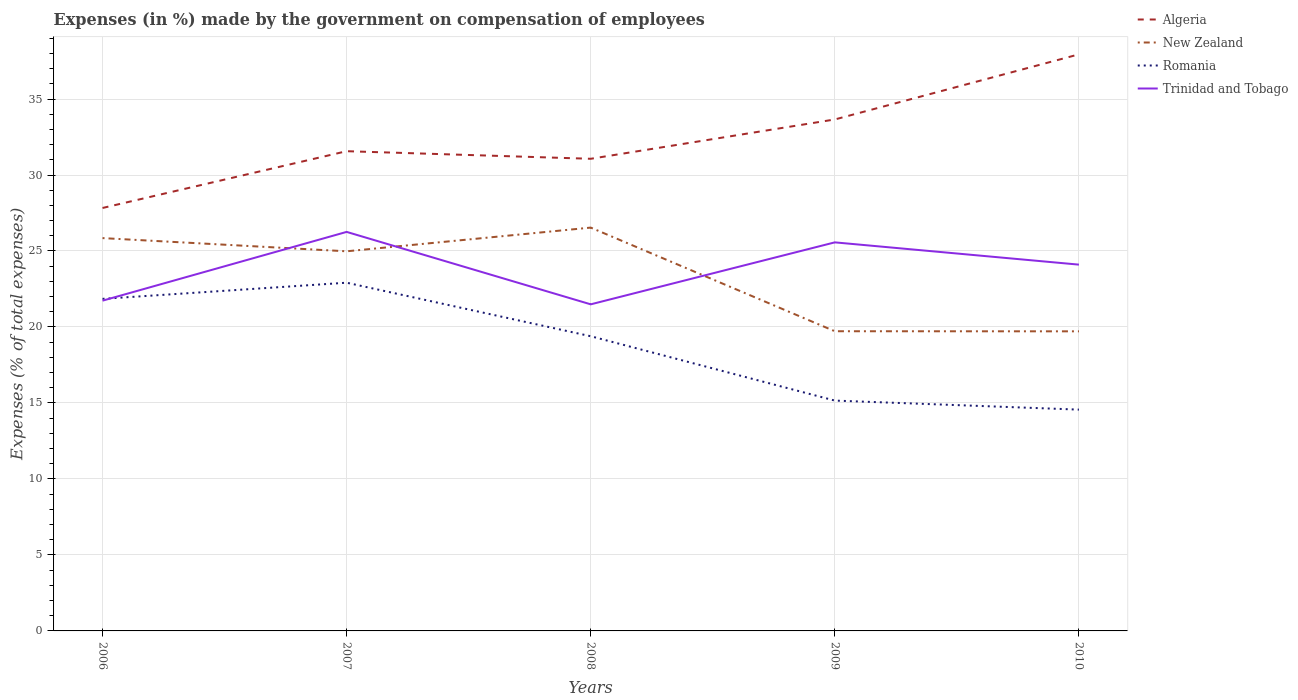Does the line corresponding to New Zealand intersect with the line corresponding to Trinidad and Tobago?
Provide a short and direct response. Yes. Across all years, what is the maximum percentage of expenses made by the government on compensation of employees in Trinidad and Tobago?
Offer a very short reply. 21.49. What is the total percentage of expenses made by the government on compensation of employees in New Zealand in the graph?
Your answer should be compact. 6.14. What is the difference between the highest and the second highest percentage of expenses made by the government on compensation of employees in Romania?
Provide a short and direct response. 8.35. How many lines are there?
Offer a very short reply. 4. How many years are there in the graph?
Provide a short and direct response. 5. What is the difference between two consecutive major ticks on the Y-axis?
Your answer should be compact. 5. Where does the legend appear in the graph?
Provide a short and direct response. Top right. How are the legend labels stacked?
Your response must be concise. Vertical. What is the title of the graph?
Your response must be concise. Expenses (in %) made by the government on compensation of employees. Does "Greece" appear as one of the legend labels in the graph?
Provide a succinct answer. No. What is the label or title of the Y-axis?
Your answer should be very brief. Expenses (% of total expenses). What is the Expenses (% of total expenses) in Algeria in 2006?
Your response must be concise. 27.83. What is the Expenses (% of total expenses) in New Zealand in 2006?
Ensure brevity in your answer.  25.85. What is the Expenses (% of total expenses) of Romania in 2006?
Your answer should be compact. 21.85. What is the Expenses (% of total expenses) in Trinidad and Tobago in 2006?
Ensure brevity in your answer.  21.73. What is the Expenses (% of total expenses) of Algeria in 2007?
Offer a terse response. 31.57. What is the Expenses (% of total expenses) in New Zealand in 2007?
Make the answer very short. 24.98. What is the Expenses (% of total expenses) in Romania in 2007?
Give a very brief answer. 22.91. What is the Expenses (% of total expenses) of Trinidad and Tobago in 2007?
Your answer should be compact. 26.26. What is the Expenses (% of total expenses) of Algeria in 2008?
Your response must be concise. 31.07. What is the Expenses (% of total expenses) in New Zealand in 2008?
Your answer should be very brief. 26.54. What is the Expenses (% of total expenses) of Romania in 2008?
Give a very brief answer. 19.39. What is the Expenses (% of total expenses) of Trinidad and Tobago in 2008?
Your answer should be very brief. 21.49. What is the Expenses (% of total expenses) of Algeria in 2009?
Offer a terse response. 33.66. What is the Expenses (% of total expenses) in New Zealand in 2009?
Your answer should be very brief. 19.72. What is the Expenses (% of total expenses) in Romania in 2009?
Make the answer very short. 15.16. What is the Expenses (% of total expenses) of Trinidad and Tobago in 2009?
Keep it short and to the point. 25.57. What is the Expenses (% of total expenses) in Algeria in 2010?
Your response must be concise. 37.94. What is the Expenses (% of total expenses) in New Zealand in 2010?
Make the answer very short. 19.71. What is the Expenses (% of total expenses) of Romania in 2010?
Provide a short and direct response. 14.56. What is the Expenses (% of total expenses) in Trinidad and Tobago in 2010?
Offer a very short reply. 24.1. Across all years, what is the maximum Expenses (% of total expenses) in Algeria?
Provide a succinct answer. 37.94. Across all years, what is the maximum Expenses (% of total expenses) of New Zealand?
Offer a terse response. 26.54. Across all years, what is the maximum Expenses (% of total expenses) in Romania?
Your answer should be very brief. 22.91. Across all years, what is the maximum Expenses (% of total expenses) in Trinidad and Tobago?
Offer a very short reply. 26.26. Across all years, what is the minimum Expenses (% of total expenses) of Algeria?
Your answer should be compact. 27.83. Across all years, what is the minimum Expenses (% of total expenses) in New Zealand?
Provide a succinct answer. 19.71. Across all years, what is the minimum Expenses (% of total expenses) in Romania?
Provide a succinct answer. 14.56. Across all years, what is the minimum Expenses (% of total expenses) of Trinidad and Tobago?
Keep it short and to the point. 21.49. What is the total Expenses (% of total expenses) in Algeria in the graph?
Keep it short and to the point. 162.06. What is the total Expenses (% of total expenses) of New Zealand in the graph?
Give a very brief answer. 116.8. What is the total Expenses (% of total expenses) of Romania in the graph?
Offer a very short reply. 93.87. What is the total Expenses (% of total expenses) of Trinidad and Tobago in the graph?
Give a very brief answer. 119.15. What is the difference between the Expenses (% of total expenses) in Algeria in 2006 and that in 2007?
Ensure brevity in your answer.  -3.74. What is the difference between the Expenses (% of total expenses) in New Zealand in 2006 and that in 2007?
Offer a terse response. 0.87. What is the difference between the Expenses (% of total expenses) in Romania in 2006 and that in 2007?
Keep it short and to the point. -1.06. What is the difference between the Expenses (% of total expenses) in Trinidad and Tobago in 2006 and that in 2007?
Offer a terse response. -4.53. What is the difference between the Expenses (% of total expenses) in Algeria in 2006 and that in 2008?
Your answer should be compact. -3.24. What is the difference between the Expenses (% of total expenses) of New Zealand in 2006 and that in 2008?
Offer a very short reply. -0.69. What is the difference between the Expenses (% of total expenses) in Romania in 2006 and that in 2008?
Give a very brief answer. 2.46. What is the difference between the Expenses (% of total expenses) in Trinidad and Tobago in 2006 and that in 2008?
Your answer should be compact. 0.24. What is the difference between the Expenses (% of total expenses) of Algeria in 2006 and that in 2009?
Provide a short and direct response. -5.83. What is the difference between the Expenses (% of total expenses) of New Zealand in 2006 and that in 2009?
Provide a succinct answer. 6.13. What is the difference between the Expenses (% of total expenses) in Romania in 2006 and that in 2009?
Offer a terse response. 6.69. What is the difference between the Expenses (% of total expenses) in Trinidad and Tobago in 2006 and that in 2009?
Give a very brief answer. -3.84. What is the difference between the Expenses (% of total expenses) of Algeria in 2006 and that in 2010?
Give a very brief answer. -10.11. What is the difference between the Expenses (% of total expenses) in New Zealand in 2006 and that in 2010?
Offer a very short reply. 6.14. What is the difference between the Expenses (% of total expenses) of Romania in 2006 and that in 2010?
Ensure brevity in your answer.  7.29. What is the difference between the Expenses (% of total expenses) in Trinidad and Tobago in 2006 and that in 2010?
Your answer should be compact. -2.37. What is the difference between the Expenses (% of total expenses) of Algeria in 2007 and that in 2008?
Your answer should be compact. 0.5. What is the difference between the Expenses (% of total expenses) in New Zealand in 2007 and that in 2008?
Make the answer very short. -1.56. What is the difference between the Expenses (% of total expenses) in Romania in 2007 and that in 2008?
Ensure brevity in your answer.  3.52. What is the difference between the Expenses (% of total expenses) in Trinidad and Tobago in 2007 and that in 2008?
Make the answer very short. 4.77. What is the difference between the Expenses (% of total expenses) in Algeria in 2007 and that in 2009?
Make the answer very short. -2.09. What is the difference between the Expenses (% of total expenses) in New Zealand in 2007 and that in 2009?
Make the answer very short. 5.26. What is the difference between the Expenses (% of total expenses) of Romania in 2007 and that in 2009?
Ensure brevity in your answer.  7.76. What is the difference between the Expenses (% of total expenses) of Trinidad and Tobago in 2007 and that in 2009?
Offer a terse response. 0.69. What is the difference between the Expenses (% of total expenses) of Algeria in 2007 and that in 2010?
Give a very brief answer. -6.37. What is the difference between the Expenses (% of total expenses) of New Zealand in 2007 and that in 2010?
Make the answer very short. 5.27. What is the difference between the Expenses (% of total expenses) in Romania in 2007 and that in 2010?
Offer a very short reply. 8.35. What is the difference between the Expenses (% of total expenses) in Trinidad and Tobago in 2007 and that in 2010?
Ensure brevity in your answer.  2.15. What is the difference between the Expenses (% of total expenses) of Algeria in 2008 and that in 2009?
Your answer should be compact. -2.59. What is the difference between the Expenses (% of total expenses) of New Zealand in 2008 and that in 2009?
Your answer should be very brief. 6.82. What is the difference between the Expenses (% of total expenses) in Romania in 2008 and that in 2009?
Make the answer very short. 4.23. What is the difference between the Expenses (% of total expenses) of Trinidad and Tobago in 2008 and that in 2009?
Provide a short and direct response. -4.08. What is the difference between the Expenses (% of total expenses) in Algeria in 2008 and that in 2010?
Offer a very short reply. -6.87. What is the difference between the Expenses (% of total expenses) in New Zealand in 2008 and that in 2010?
Your answer should be compact. 6.83. What is the difference between the Expenses (% of total expenses) in Romania in 2008 and that in 2010?
Keep it short and to the point. 4.83. What is the difference between the Expenses (% of total expenses) of Trinidad and Tobago in 2008 and that in 2010?
Your answer should be compact. -2.61. What is the difference between the Expenses (% of total expenses) in Algeria in 2009 and that in 2010?
Keep it short and to the point. -4.28. What is the difference between the Expenses (% of total expenses) of New Zealand in 2009 and that in 2010?
Ensure brevity in your answer.  0.01. What is the difference between the Expenses (% of total expenses) of Romania in 2009 and that in 2010?
Your answer should be very brief. 0.59. What is the difference between the Expenses (% of total expenses) of Trinidad and Tobago in 2009 and that in 2010?
Give a very brief answer. 1.47. What is the difference between the Expenses (% of total expenses) of Algeria in 2006 and the Expenses (% of total expenses) of New Zealand in 2007?
Your answer should be very brief. 2.85. What is the difference between the Expenses (% of total expenses) of Algeria in 2006 and the Expenses (% of total expenses) of Romania in 2007?
Your response must be concise. 4.92. What is the difference between the Expenses (% of total expenses) of Algeria in 2006 and the Expenses (% of total expenses) of Trinidad and Tobago in 2007?
Make the answer very short. 1.57. What is the difference between the Expenses (% of total expenses) of New Zealand in 2006 and the Expenses (% of total expenses) of Romania in 2007?
Your answer should be compact. 2.94. What is the difference between the Expenses (% of total expenses) in New Zealand in 2006 and the Expenses (% of total expenses) in Trinidad and Tobago in 2007?
Your response must be concise. -0.41. What is the difference between the Expenses (% of total expenses) of Romania in 2006 and the Expenses (% of total expenses) of Trinidad and Tobago in 2007?
Your answer should be very brief. -4.41. What is the difference between the Expenses (% of total expenses) in Algeria in 2006 and the Expenses (% of total expenses) in New Zealand in 2008?
Provide a short and direct response. 1.29. What is the difference between the Expenses (% of total expenses) of Algeria in 2006 and the Expenses (% of total expenses) of Romania in 2008?
Your answer should be very brief. 8.44. What is the difference between the Expenses (% of total expenses) of Algeria in 2006 and the Expenses (% of total expenses) of Trinidad and Tobago in 2008?
Provide a short and direct response. 6.34. What is the difference between the Expenses (% of total expenses) in New Zealand in 2006 and the Expenses (% of total expenses) in Romania in 2008?
Offer a terse response. 6.46. What is the difference between the Expenses (% of total expenses) of New Zealand in 2006 and the Expenses (% of total expenses) of Trinidad and Tobago in 2008?
Keep it short and to the point. 4.36. What is the difference between the Expenses (% of total expenses) in Romania in 2006 and the Expenses (% of total expenses) in Trinidad and Tobago in 2008?
Your answer should be compact. 0.36. What is the difference between the Expenses (% of total expenses) in Algeria in 2006 and the Expenses (% of total expenses) in New Zealand in 2009?
Provide a short and direct response. 8.11. What is the difference between the Expenses (% of total expenses) of Algeria in 2006 and the Expenses (% of total expenses) of Romania in 2009?
Give a very brief answer. 12.67. What is the difference between the Expenses (% of total expenses) in Algeria in 2006 and the Expenses (% of total expenses) in Trinidad and Tobago in 2009?
Keep it short and to the point. 2.26. What is the difference between the Expenses (% of total expenses) in New Zealand in 2006 and the Expenses (% of total expenses) in Romania in 2009?
Make the answer very short. 10.69. What is the difference between the Expenses (% of total expenses) of New Zealand in 2006 and the Expenses (% of total expenses) of Trinidad and Tobago in 2009?
Keep it short and to the point. 0.28. What is the difference between the Expenses (% of total expenses) of Romania in 2006 and the Expenses (% of total expenses) of Trinidad and Tobago in 2009?
Your answer should be compact. -3.72. What is the difference between the Expenses (% of total expenses) of Algeria in 2006 and the Expenses (% of total expenses) of New Zealand in 2010?
Your response must be concise. 8.12. What is the difference between the Expenses (% of total expenses) of Algeria in 2006 and the Expenses (% of total expenses) of Romania in 2010?
Your response must be concise. 13.27. What is the difference between the Expenses (% of total expenses) of Algeria in 2006 and the Expenses (% of total expenses) of Trinidad and Tobago in 2010?
Ensure brevity in your answer.  3.73. What is the difference between the Expenses (% of total expenses) in New Zealand in 2006 and the Expenses (% of total expenses) in Romania in 2010?
Provide a short and direct response. 11.29. What is the difference between the Expenses (% of total expenses) in New Zealand in 2006 and the Expenses (% of total expenses) in Trinidad and Tobago in 2010?
Provide a short and direct response. 1.75. What is the difference between the Expenses (% of total expenses) of Romania in 2006 and the Expenses (% of total expenses) of Trinidad and Tobago in 2010?
Give a very brief answer. -2.25. What is the difference between the Expenses (% of total expenses) of Algeria in 2007 and the Expenses (% of total expenses) of New Zealand in 2008?
Your response must be concise. 5.03. What is the difference between the Expenses (% of total expenses) of Algeria in 2007 and the Expenses (% of total expenses) of Romania in 2008?
Ensure brevity in your answer.  12.18. What is the difference between the Expenses (% of total expenses) of Algeria in 2007 and the Expenses (% of total expenses) of Trinidad and Tobago in 2008?
Offer a very short reply. 10.08. What is the difference between the Expenses (% of total expenses) in New Zealand in 2007 and the Expenses (% of total expenses) in Romania in 2008?
Offer a very short reply. 5.59. What is the difference between the Expenses (% of total expenses) in New Zealand in 2007 and the Expenses (% of total expenses) in Trinidad and Tobago in 2008?
Keep it short and to the point. 3.49. What is the difference between the Expenses (% of total expenses) in Romania in 2007 and the Expenses (% of total expenses) in Trinidad and Tobago in 2008?
Provide a short and direct response. 1.42. What is the difference between the Expenses (% of total expenses) in Algeria in 2007 and the Expenses (% of total expenses) in New Zealand in 2009?
Offer a very short reply. 11.85. What is the difference between the Expenses (% of total expenses) of Algeria in 2007 and the Expenses (% of total expenses) of Romania in 2009?
Your answer should be compact. 16.41. What is the difference between the Expenses (% of total expenses) in Algeria in 2007 and the Expenses (% of total expenses) in Trinidad and Tobago in 2009?
Offer a terse response. 6. What is the difference between the Expenses (% of total expenses) in New Zealand in 2007 and the Expenses (% of total expenses) in Romania in 2009?
Keep it short and to the point. 9.82. What is the difference between the Expenses (% of total expenses) of New Zealand in 2007 and the Expenses (% of total expenses) of Trinidad and Tobago in 2009?
Offer a very short reply. -0.59. What is the difference between the Expenses (% of total expenses) in Romania in 2007 and the Expenses (% of total expenses) in Trinidad and Tobago in 2009?
Give a very brief answer. -2.65. What is the difference between the Expenses (% of total expenses) in Algeria in 2007 and the Expenses (% of total expenses) in New Zealand in 2010?
Your answer should be very brief. 11.85. What is the difference between the Expenses (% of total expenses) of Algeria in 2007 and the Expenses (% of total expenses) of Romania in 2010?
Give a very brief answer. 17.01. What is the difference between the Expenses (% of total expenses) in Algeria in 2007 and the Expenses (% of total expenses) in Trinidad and Tobago in 2010?
Provide a short and direct response. 7.46. What is the difference between the Expenses (% of total expenses) in New Zealand in 2007 and the Expenses (% of total expenses) in Romania in 2010?
Make the answer very short. 10.42. What is the difference between the Expenses (% of total expenses) in New Zealand in 2007 and the Expenses (% of total expenses) in Trinidad and Tobago in 2010?
Keep it short and to the point. 0.88. What is the difference between the Expenses (% of total expenses) of Romania in 2007 and the Expenses (% of total expenses) of Trinidad and Tobago in 2010?
Offer a very short reply. -1.19. What is the difference between the Expenses (% of total expenses) in Algeria in 2008 and the Expenses (% of total expenses) in New Zealand in 2009?
Provide a succinct answer. 11.35. What is the difference between the Expenses (% of total expenses) in Algeria in 2008 and the Expenses (% of total expenses) in Romania in 2009?
Keep it short and to the point. 15.91. What is the difference between the Expenses (% of total expenses) in Algeria in 2008 and the Expenses (% of total expenses) in Trinidad and Tobago in 2009?
Your answer should be compact. 5.5. What is the difference between the Expenses (% of total expenses) in New Zealand in 2008 and the Expenses (% of total expenses) in Romania in 2009?
Offer a terse response. 11.38. What is the difference between the Expenses (% of total expenses) of New Zealand in 2008 and the Expenses (% of total expenses) of Trinidad and Tobago in 2009?
Give a very brief answer. 0.97. What is the difference between the Expenses (% of total expenses) in Romania in 2008 and the Expenses (% of total expenses) in Trinidad and Tobago in 2009?
Offer a very short reply. -6.18. What is the difference between the Expenses (% of total expenses) of Algeria in 2008 and the Expenses (% of total expenses) of New Zealand in 2010?
Keep it short and to the point. 11.35. What is the difference between the Expenses (% of total expenses) in Algeria in 2008 and the Expenses (% of total expenses) in Romania in 2010?
Your response must be concise. 16.51. What is the difference between the Expenses (% of total expenses) in Algeria in 2008 and the Expenses (% of total expenses) in Trinidad and Tobago in 2010?
Keep it short and to the point. 6.97. What is the difference between the Expenses (% of total expenses) in New Zealand in 2008 and the Expenses (% of total expenses) in Romania in 2010?
Your answer should be very brief. 11.98. What is the difference between the Expenses (% of total expenses) in New Zealand in 2008 and the Expenses (% of total expenses) in Trinidad and Tobago in 2010?
Your answer should be compact. 2.44. What is the difference between the Expenses (% of total expenses) in Romania in 2008 and the Expenses (% of total expenses) in Trinidad and Tobago in 2010?
Your answer should be very brief. -4.71. What is the difference between the Expenses (% of total expenses) of Algeria in 2009 and the Expenses (% of total expenses) of New Zealand in 2010?
Give a very brief answer. 13.94. What is the difference between the Expenses (% of total expenses) of Algeria in 2009 and the Expenses (% of total expenses) of Romania in 2010?
Provide a short and direct response. 19.09. What is the difference between the Expenses (% of total expenses) of Algeria in 2009 and the Expenses (% of total expenses) of Trinidad and Tobago in 2010?
Provide a succinct answer. 9.55. What is the difference between the Expenses (% of total expenses) of New Zealand in 2009 and the Expenses (% of total expenses) of Romania in 2010?
Your answer should be compact. 5.16. What is the difference between the Expenses (% of total expenses) of New Zealand in 2009 and the Expenses (% of total expenses) of Trinidad and Tobago in 2010?
Ensure brevity in your answer.  -4.38. What is the difference between the Expenses (% of total expenses) in Romania in 2009 and the Expenses (% of total expenses) in Trinidad and Tobago in 2010?
Provide a short and direct response. -8.95. What is the average Expenses (% of total expenses) of Algeria per year?
Give a very brief answer. 32.41. What is the average Expenses (% of total expenses) in New Zealand per year?
Offer a terse response. 23.36. What is the average Expenses (% of total expenses) in Romania per year?
Give a very brief answer. 18.77. What is the average Expenses (% of total expenses) in Trinidad and Tobago per year?
Offer a very short reply. 23.83. In the year 2006, what is the difference between the Expenses (% of total expenses) in Algeria and Expenses (% of total expenses) in New Zealand?
Ensure brevity in your answer.  1.98. In the year 2006, what is the difference between the Expenses (% of total expenses) in Algeria and Expenses (% of total expenses) in Romania?
Ensure brevity in your answer.  5.98. In the year 2006, what is the difference between the Expenses (% of total expenses) of Algeria and Expenses (% of total expenses) of Trinidad and Tobago?
Give a very brief answer. 6.1. In the year 2006, what is the difference between the Expenses (% of total expenses) in New Zealand and Expenses (% of total expenses) in Romania?
Your answer should be very brief. 4. In the year 2006, what is the difference between the Expenses (% of total expenses) of New Zealand and Expenses (% of total expenses) of Trinidad and Tobago?
Your answer should be compact. 4.12. In the year 2006, what is the difference between the Expenses (% of total expenses) of Romania and Expenses (% of total expenses) of Trinidad and Tobago?
Keep it short and to the point. 0.12. In the year 2007, what is the difference between the Expenses (% of total expenses) in Algeria and Expenses (% of total expenses) in New Zealand?
Ensure brevity in your answer.  6.59. In the year 2007, what is the difference between the Expenses (% of total expenses) in Algeria and Expenses (% of total expenses) in Romania?
Offer a terse response. 8.65. In the year 2007, what is the difference between the Expenses (% of total expenses) of Algeria and Expenses (% of total expenses) of Trinidad and Tobago?
Your response must be concise. 5.31. In the year 2007, what is the difference between the Expenses (% of total expenses) in New Zealand and Expenses (% of total expenses) in Romania?
Keep it short and to the point. 2.07. In the year 2007, what is the difference between the Expenses (% of total expenses) in New Zealand and Expenses (% of total expenses) in Trinidad and Tobago?
Your answer should be compact. -1.28. In the year 2007, what is the difference between the Expenses (% of total expenses) of Romania and Expenses (% of total expenses) of Trinidad and Tobago?
Offer a terse response. -3.34. In the year 2008, what is the difference between the Expenses (% of total expenses) in Algeria and Expenses (% of total expenses) in New Zealand?
Your answer should be compact. 4.53. In the year 2008, what is the difference between the Expenses (% of total expenses) in Algeria and Expenses (% of total expenses) in Romania?
Provide a short and direct response. 11.68. In the year 2008, what is the difference between the Expenses (% of total expenses) in Algeria and Expenses (% of total expenses) in Trinidad and Tobago?
Your response must be concise. 9.58. In the year 2008, what is the difference between the Expenses (% of total expenses) of New Zealand and Expenses (% of total expenses) of Romania?
Keep it short and to the point. 7.15. In the year 2008, what is the difference between the Expenses (% of total expenses) of New Zealand and Expenses (% of total expenses) of Trinidad and Tobago?
Make the answer very short. 5.05. In the year 2008, what is the difference between the Expenses (% of total expenses) of Romania and Expenses (% of total expenses) of Trinidad and Tobago?
Your response must be concise. -2.1. In the year 2009, what is the difference between the Expenses (% of total expenses) in Algeria and Expenses (% of total expenses) in New Zealand?
Your answer should be compact. 13.94. In the year 2009, what is the difference between the Expenses (% of total expenses) of Algeria and Expenses (% of total expenses) of Romania?
Make the answer very short. 18.5. In the year 2009, what is the difference between the Expenses (% of total expenses) of Algeria and Expenses (% of total expenses) of Trinidad and Tobago?
Offer a terse response. 8.09. In the year 2009, what is the difference between the Expenses (% of total expenses) of New Zealand and Expenses (% of total expenses) of Romania?
Provide a short and direct response. 4.56. In the year 2009, what is the difference between the Expenses (% of total expenses) in New Zealand and Expenses (% of total expenses) in Trinidad and Tobago?
Offer a very short reply. -5.85. In the year 2009, what is the difference between the Expenses (% of total expenses) in Romania and Expenses (% of total expenses) in Trinidad and Tobago?
Give a very brief answer. -10.41. In the year 2010, what is the difference between the Expenses (% of total expenses) in Algeria and Expenses (% of total expenses) in New Zealand?
Ensure brevity in your answer.  18.23. In the year 2010, what is the difference between the Expenses (% of total expenses) in Algeria and Expenses (% of total expenses) in Romania?
Offer a terse response. 23.38. In the year 2010, what is the difference between the Expenses (% of total expenses) of Algeria and Expenses (% of total expenses) of Trinidad and Tobago?
Your answer should be very brief. 13.84. In the year 2010, what is the difference between the Expenses (% of total expenses) in New Zealand and Expenses (% of total expenses) in Romania?
Offer a terse response. 5.15. In the year 2010, what is the difference between the Expenses (% of total expenses) in New Zealand and Expenses (% of total expenses) in Trinidad and Tobago?
Ensure brevity in your answer.  -4.39. In the year 2010, what is the difference between the Expenses (% of total expenses) in Romania and Expenses (% of total expenses) in Trinidad and Tobago?
Your answer should be very brief. -9.54. What is the ratio of the Expenses (% of total expenses) in Algeria in 2006 to that in 2007?
Provide a short and direct response. 0.88. What is the ratio of the Expenses (% of total expenses) of New Zealand in 2006 to that in 2007?
Your response must be concise. 1.03. What is the ratio of the Expenses (% of total expenses) of Romania in 2006 to that in 2007?
Ensure brevity in your answer.  0.95. What is the ratio of the Expenses (% of total expenses) in Trinidad and Tobago in 2006 to that in 2007?
Your answer should be compact. 0.83. What is the ratio of the Expenses (% of total expenses) of Algeria in 2006 to that in 2008?
Keep it short and to the point. 0.9. What is the ratio of the Expenses (% of total expenses) in Romania in 2006 to that in 2008?
Your answer should be very brief. 1.13. What is the ratio of the Expenses (% of total expenses) in Trinidad and Tobago in 2006 to that in 2008?
Your response must be concise. 1.01. What is the ratio of the Expenses (% of total expenses) in Algeria in 2006 to that in 2009?
Your answer should be very brief. 0.83. What is the ratio of the Expenses (% of total expenses) in New Zealand in 2006 to that in 2009?
Your answer should be compact. 1.31. What is the ratio of the Expenses (% of total expenses) of Romania in 2006 to that in 2009?
Your answer should be compact. 1.44. What is the ratio of the Expenses (% of total expenses) of Trinidad and Tobago in 2006 to that in 2009?
Offer a terse response. 0.85. What is the ratio of the Expenses (% of total expenses) in Algeria in 2006 to that in 2010?
Make the answer very short. 0.73. What is the ratio of the Expenses (% of total expenses) in New Zealand in 2006 to that in 2010?
Your response must be concise. 1.31. What is the ratio of the Expenses (% of total expenses) of Romania in 2006 to that in 2010?
Keep it short and to the point. 1.5. What is the ratio of the Expenses (% of total expenses) of Trinidad and Tobago in 2006 to that in 2010?
Your response must be concise. 0.9. What is the ratio of the Expenses (% of total expenses) in Algeria in 2007 to that in 2008?
Provide a short and direct response. 1.02. What is the ratio of the Expenses (% of total expenses) of New Zealand in 2007 to that in 2008?
Offer a very short reply. 0.94. What is the ratio of the Expenses (% of total expenses) in Romania in 2007 to that in 2008?
Ensure brevity in your answer.  1.18. What is the ratio of the Expenses (% of total expenses) of Trinidad and Tobago in 2007 to that in 2008?
Ensure brevity in your answer.  1.22. What is the ratio of the Expenses (% of total expenses) in Algeria in 2007 to that in 2009?
Ensure brevity in your answer.  0.94. What is the ratio of the Expenses (% of total expenses) of New Zealand in 2007 to that in 2009?
Provide a succinct answer. 1.27. What is the ratio of the Expenses (% of total expenses) of Romania in 2007 to that in 2009?
Provide a succinct answer. 1.51. What is the ratio of the Expenses (% of total expenses) of Trinidad and Tobago in 2007 to that in 2009?
Give a very brief answer. 1.03. What is the ratio of the Expenses (% of total expenses) of Algeria in 2007 to that in 2010?
Your answer should be compact. 0.83. What is the ratio of the Expenses (% of total expenses) in New Zealand in 2007 to that in 2010?
Offer a very short reply. 1.27. What is the ratio of the Expenses (% of total expenses) in Romania in 2007 to that in 2010?
Make the answer very short. 1.57. What is the ratio of the Expenses (% of total expenses) of Trinidad and Tobago in 2007 to that in 2010?
Your answer should be very brief. 1.09. What is the ratio of the Expenses (% of total expenses) of Algeria in 2008 to that in 2009?
Give a very brief answer. 0.92. What is the ratio of the Expenses (% of total expenses) of New Zealand in 2008 to that in 2009?
Ensure brevity in your answer.  1.35. What is the ratio of the Expenses (% of total expenses) of Romania in 2008 to that in 2009?
Offer a terse response. 1.28. What is the ratio of the Expenses (% of total expenses) in Trinidad and Tobago in 2008 to that in 2009?
Give a very brief answer. 0.84. What is the ratio of the Expenses (% of total expenses) in Algeria in 2008 to that in 2010?
Provide a succinct answer. 0.82. What is the ratio of the Expenses (% of total expenses) in New Zealand in 2008 to that in 2010?
Keep it short and to the point. 1.35. What is the ratio of the Expenses (% of total expenses) of Romania in 2008 to that in 2010?
Give a very brief answer. 1.33. What is the ratio of the Expenses (% of total expenses) of Trinidad and Tobago in 2008 to that in 2010?
Offer a very short reply. 0.89. What is the ratio of the Expenses (% of total expenses) in Algeria in 2009 to that in 2010?
Your answer should be very brief. 0.89. What is the ratio of the Expenses (% of total expenses) in New Zealand in 2009 to that in 2010?
Offer a terse response. 1. What is the ratio of the Expenses (% of total expenses) of Romania in 2009 to that in 2010?
Keep it short and to the point. 1.04. What is the ratio of the Expenses (% of total expenses) in Trinidad and Tobago in 2009 to that in 2010?
Keep it short and to the point. 1.06. What is the difference between the highest and the second highest Expenses (% of total expenses) in Algeria?
Provide a short and direct response. 4.28. What is the difference between the highest and the second highest Expenses (% of total expenses) of New Zealand?
Your answer should be compact. 0.69. What is the difference between the highest and the second highest Expenses (% of total expenses) of Romania?
Make the answer very short. 1.06. What is the difference between the highest and the second highest Expenses (% of total expenses) in Trinidad and Tobago?
Keep it short and to the point. 0.69. What is the difference between the highest and the lowest Expenses (% of total expenses) in Algeria?
Your answer should be compact. 10.11. What is the difference between the highest and the lowest Expenses (% of total expenses) of New Zealand?
Offer a terse response. 6.83. What is the difference between the highest and the lowest Expenses (% of total expenses) in Romania?
Offer a terse response. 8.35. What is the difference between the highest and the lowest Expenses (% of total expenses) of Trinidad and Tobago?
Provide a short and direct response. 4.77. 